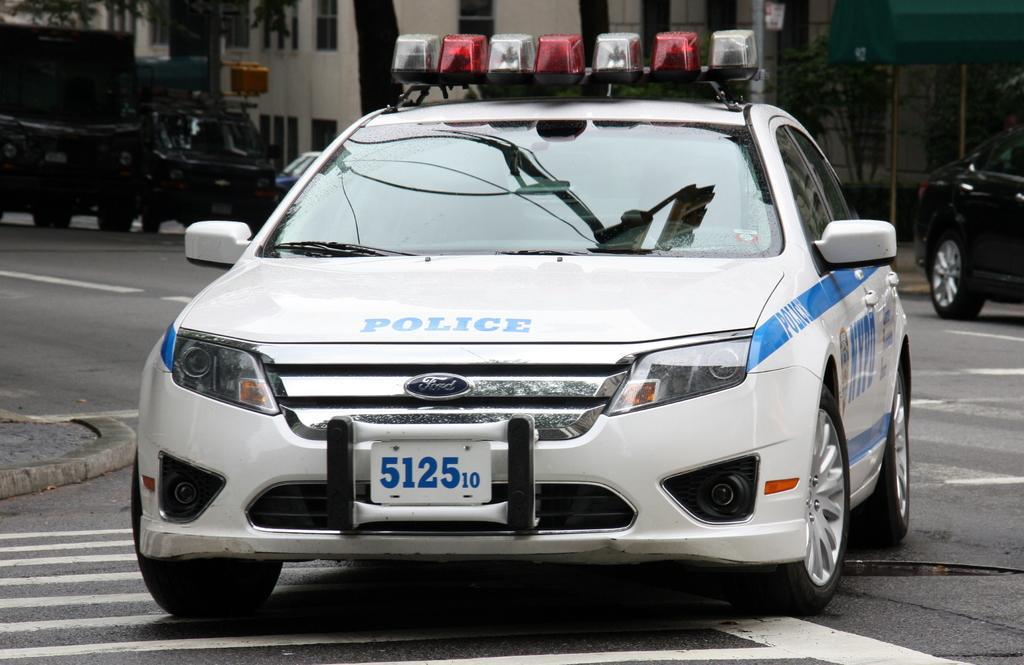In one or two sentences, can you explain what this image depicts? In this image, there are a few vehicles, trees, poles, buildings. We can also see the ground. We can also see some object in the top right corner. 